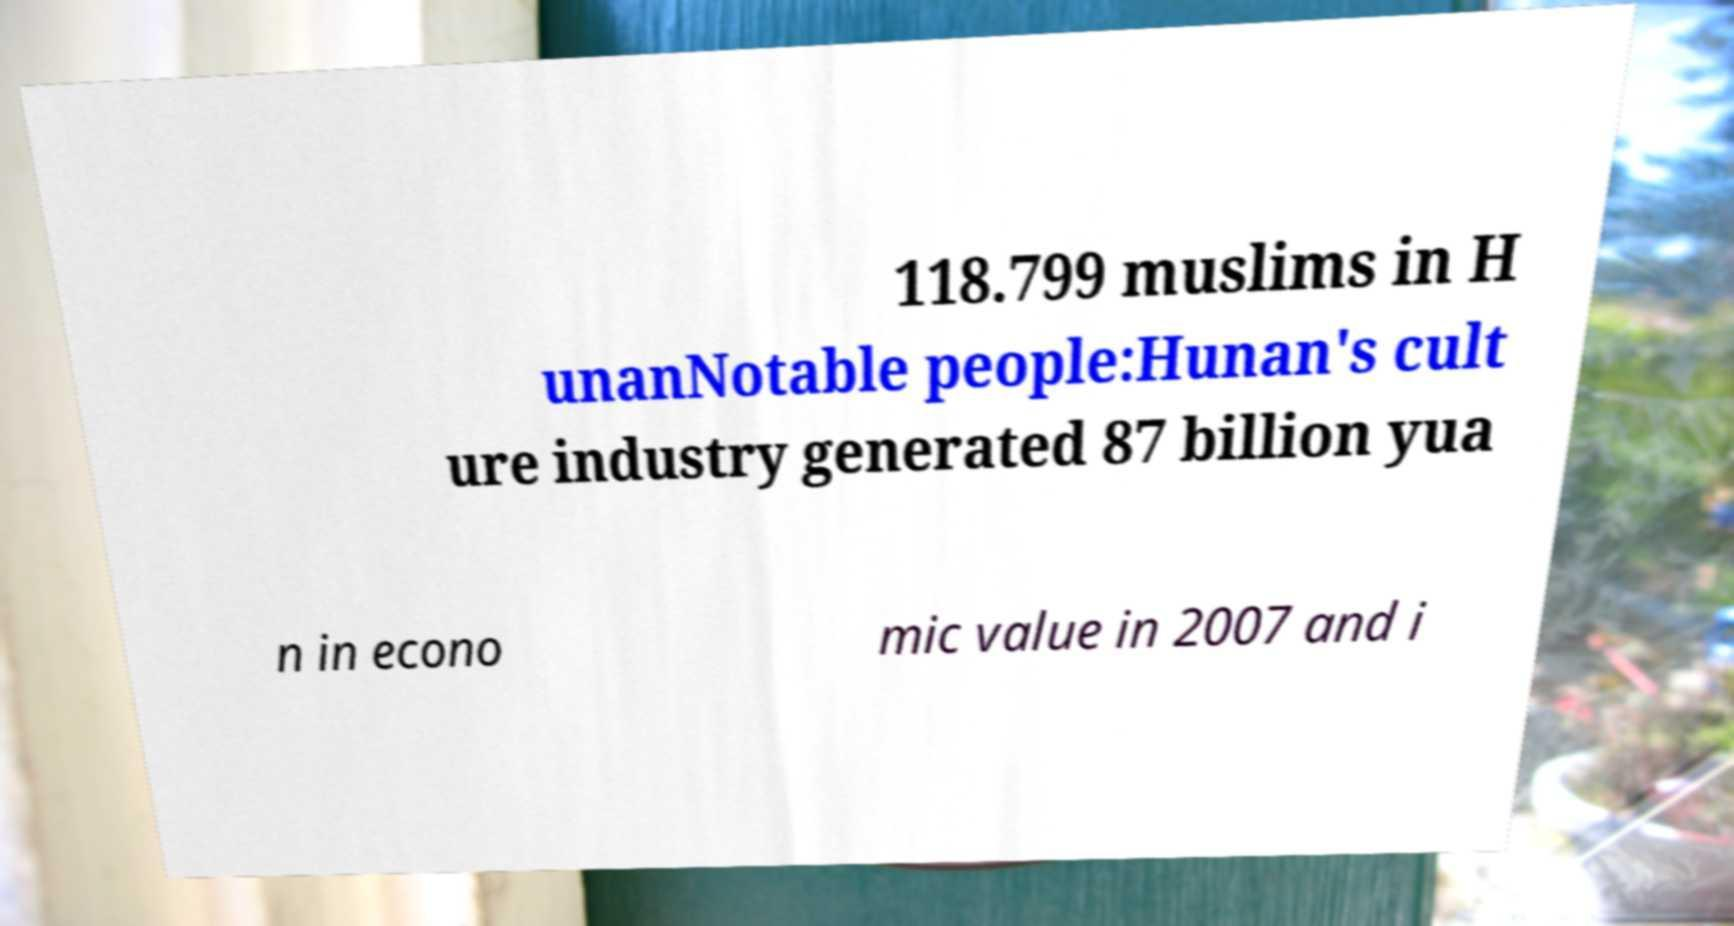What messages or text are displayed in this image? I need them in a readable, typed format. 118.799 muslims in H unanNotable people:Hunan's cult ure industry generated 87 billion yua n in econo mic value in 2007 and i 